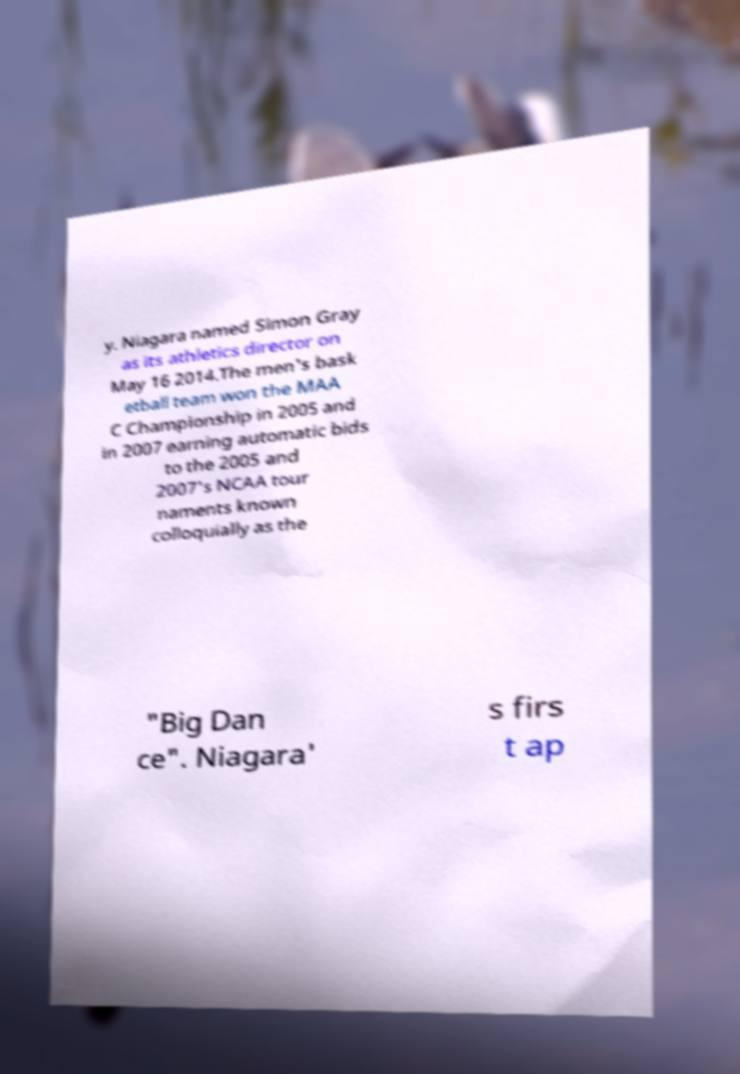Please read and relay the text visible in this image. What does it say? y. Niagara named Simon Gray as its athletics director on May 16 2014.The men's bask etball team won the MAA C Championship in 2005 and in 2007 earning automatic bids to the 2005 and 2007's NCAA tour naments known colloquially as the "Big Dan ce". Niagara' s firs t ap 